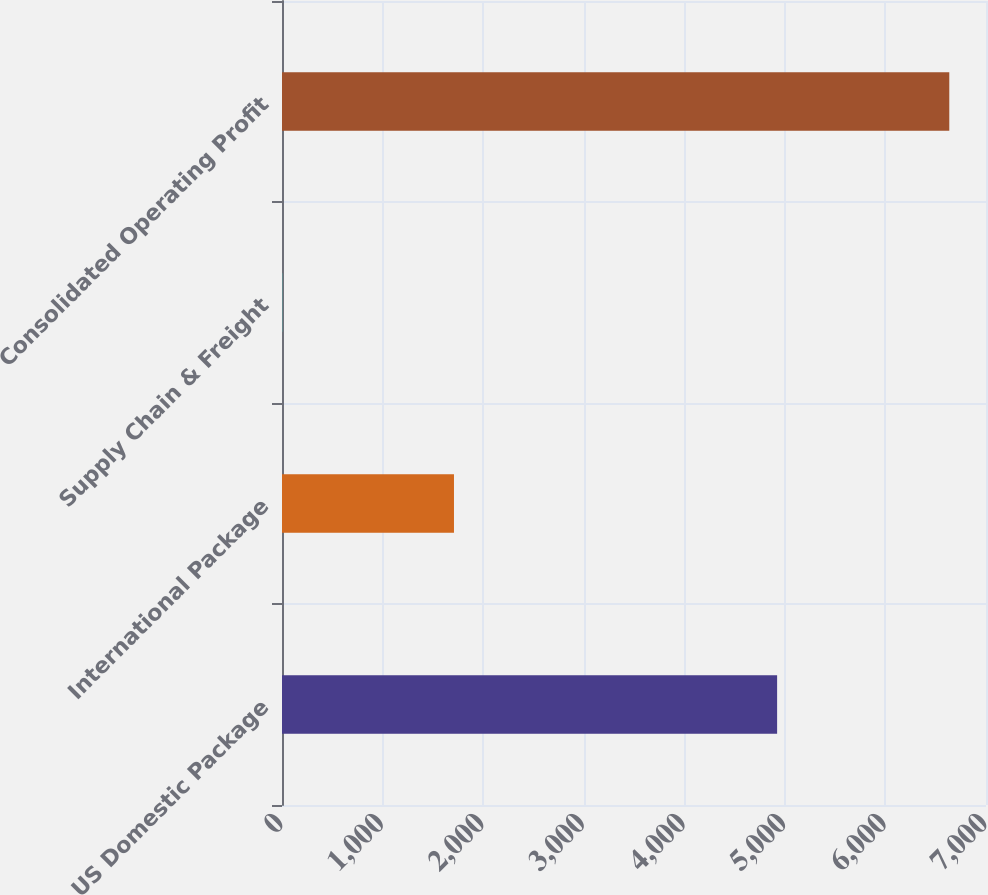<chart> <loc_0><loc_0><loc_500><loc_500><bar_chart><fcel>US Domestic Package<fcel>International Package<fcel>Supply Chain & Freight<fcel>Consolidated Operating Profit<nl><fcel>4923<fcel>1710<fcel>2<fcel>6635<nl></chart> 